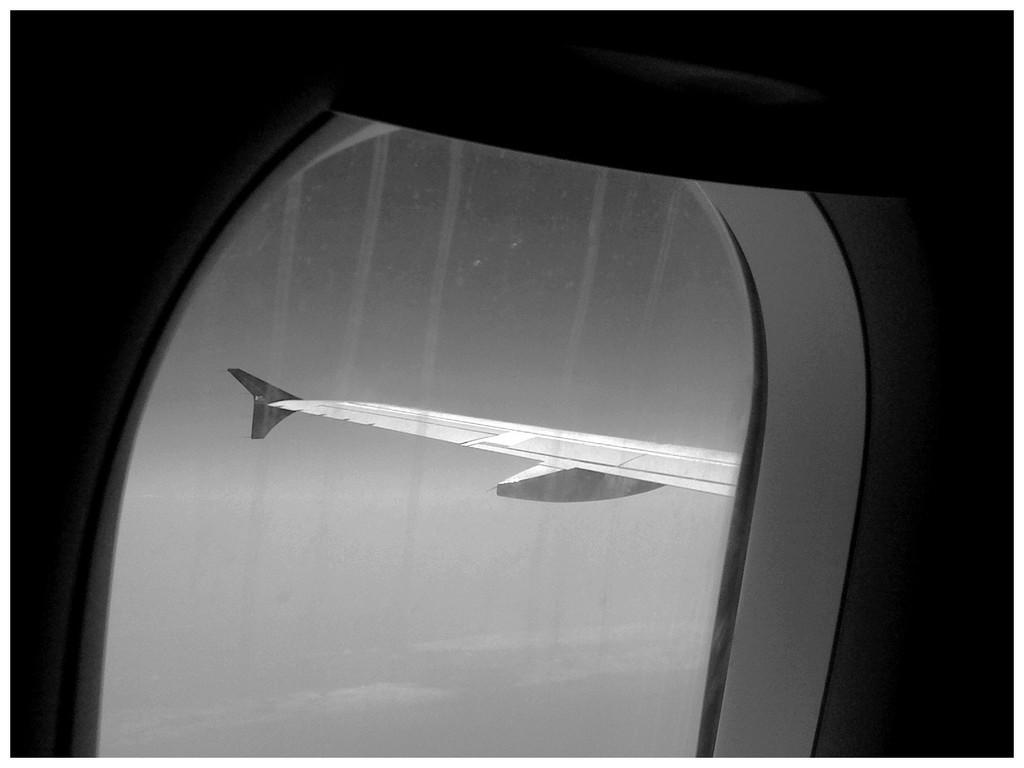In one or two sentences, can you explain what this image depicts? In the picture we can see wing of an airplane through the window and there is clear sky. 